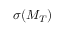Convert formula to latex. <formula><loc_0><loc_0><loc_500><loc_500>\sigma ( M _ { T } )</formula> 